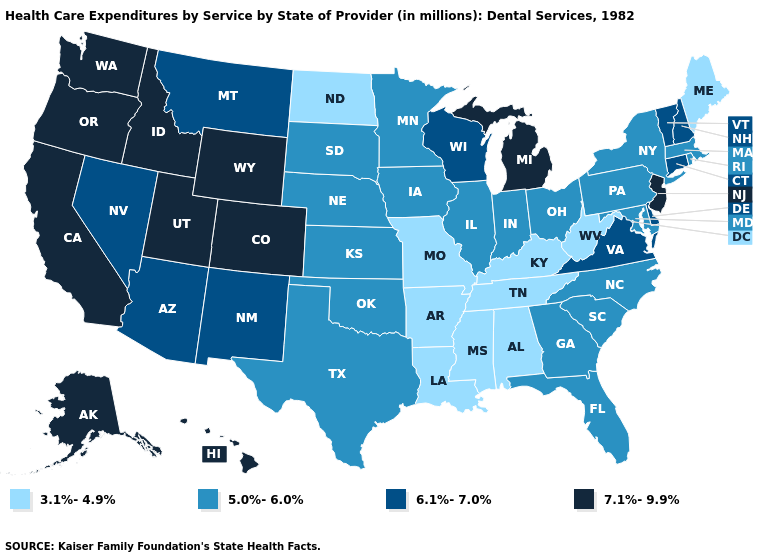Name the states that have a value in the range 6.1%-7.0%?
Short answer required. Arizona, Connecticut, Delaware, Montana, Nevada, New Hampshire, New Mexico, Vermont, Virginia, Wisconsin. What is the value of South Carolina?
Keep it brief. 5.0%-6.0%. Among the states that border Vermont , which have the highest value?
Keep it brief. New Hampshire. What is the value of Florida?
Keep it brief. 5.0%-6.0%. Name the states that have a value in the range 6.1%-7.0%?
Short answer required. Arizona, Connecticut, Delaware, Montana, Nevada, New Hampshire, New Mexico, Vermont, Virginia, Wisconsin. Name the states that have a value in the range 6.1%-7.0%?
Write a very short answer. Arizona, Connecticut, Delaware, Montana, Nevada, New Hampshire, New Mexico, Vermont, Virginia, Wisconsin. Which states have the lowest value in the USA?
Keep it brief. Alabama, Arkansas, Kentucky, Louisiana, Maine, Mississippi, Missouri, North Dakota, Tennessee, West Virginia. Does Oregon have the lowest value in the USA?
Short answer required. No. Does Nevada have a higher value than Rhode Island?
Keep it brief. Yes. What is the value of Missouri?
Quick response, please. 3.1%-4.9%. Among the states that border New Hampshire , does Vermont have the highest value?
Give a very brief answer. Yes. Name the states that have a value in the range 7.1%-9.9%?
Give a very brief answer. Alaska, California, Colorado, Hawaii, Idaho, Michigan, New Jersey, Oregon, Utah, Washington, Wyoming. What is the highest value in states that border Kentucky?
Concise answer only. 6.1%-7.0%. What is the value of South Carolina?
Quick response, please. 5.0%-6.0%. 